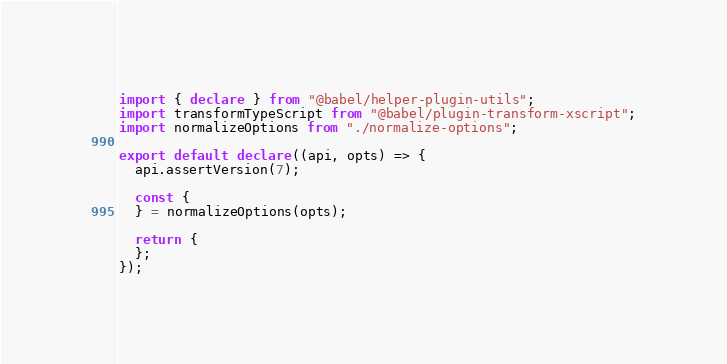Convert code to text. <code><loc_0><loc_0><loc_500><loc_500><_TypeScript_>import { declare } from "@babel/helper-plugin-utils";
import transformTypeScript from "@babel/plugin-transform-xscript";
import normalizeOptions from "./normalize-options";

export default declare((api, opts) => {
  api.assertVersion(7);

  const {
  } = normalizeOptions(opts);

  return {
  };
});
</code> 